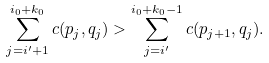Convert formula to latex. <formula><loc_0><loc_0><loc_500><loc_500>\sum _ { j = i ^ { \prime } + 1 } ^ { i _ { 0 } + k _ { 0 } } c ( p _ { j } , q _ { j } ) > \sum _ { j = i ^ { \prime } } ^ { i _ { 0 } + k _ { 0 } - 1 } c ( p _ { j + 1 } , q _ { j } ) .</formula> 